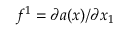Convert formula to latex. <formula><loc_0><loc_0><loc_500><loc_500>f ^ { 1 } = \partial a ( \boldsymbol x ) / \partial x _ { 1 }</formula> 